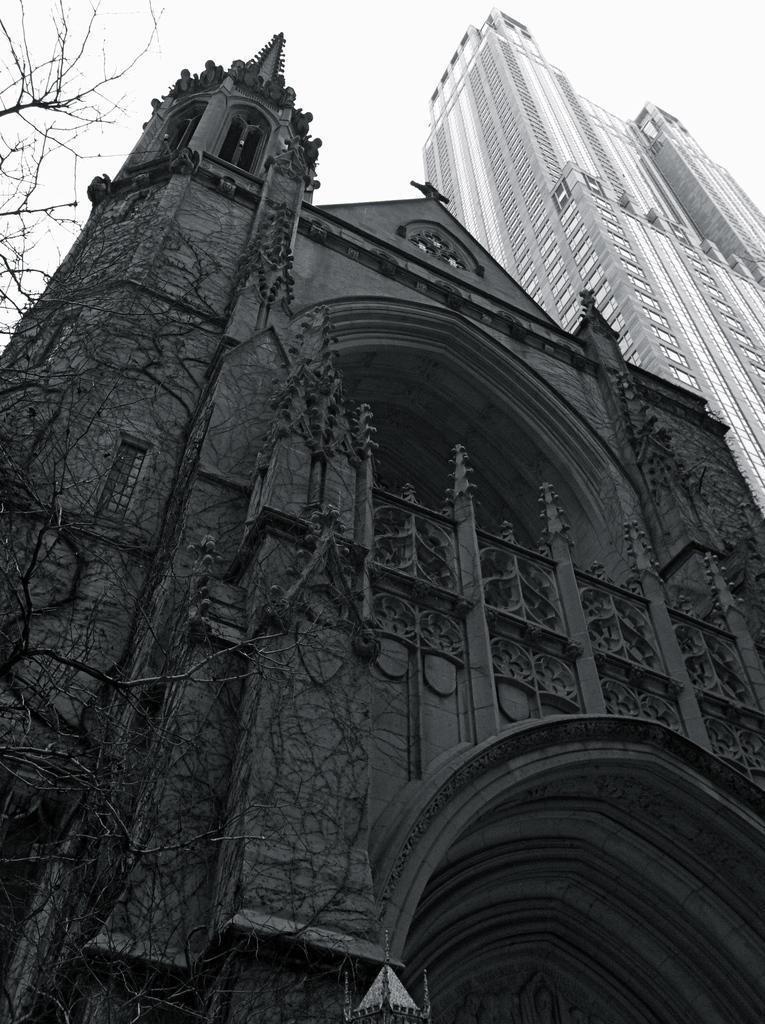In one or two sentences, can you explain what this image depicts? In this image in the center there are buildings, and there are some trees. At the top there is sky. 